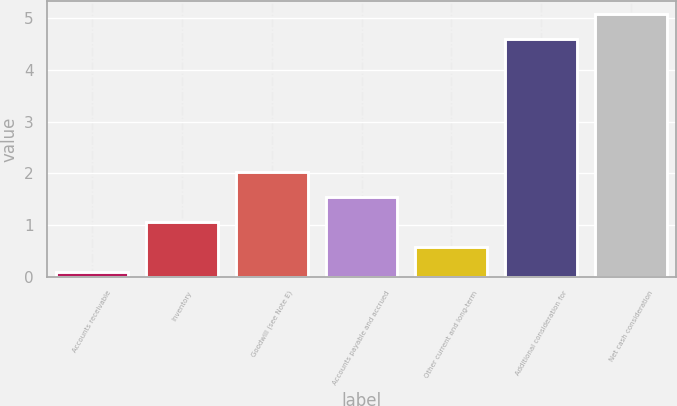<chart> <loc_0><loc_0><loc_500><loc_500><bar_chart><fcel>Accounts receivable<fcel>Inventory<fcel>Goodwill (see Note E)<fcel>Accounts payable and accrued<fcel>Other current and long-term<fcel>Additional consideration for<fcel>Net cash consideration<nl><fcel>0.1<fcel>1.06<fcel>2.02<fcel>1.54<fcel>0.58<fcel>4.6<fcel>5.08<nl></chart> 